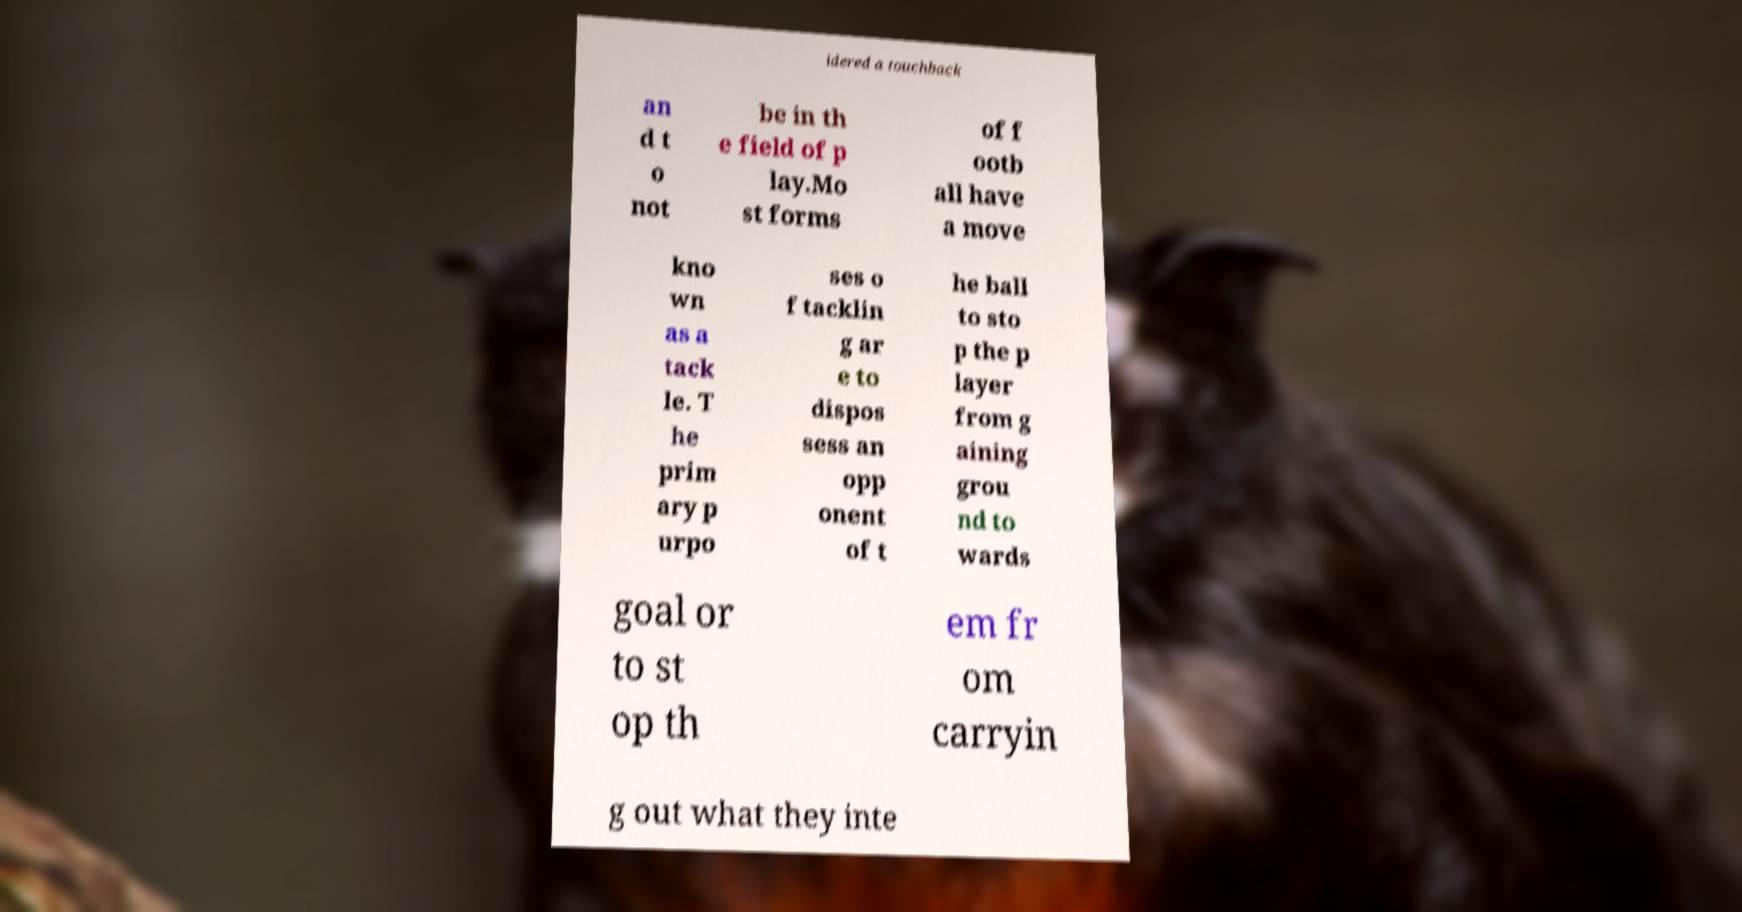Can you accurately transcribe the text from the provided image for me? idered a touchback an d t o not be in th e field of p lay.Mo st forms of f ootb all have a move kno wn as a tack le. T he prim ary p urpo ses o f tacklin g ar e to dispos sess an opp onent of t he ball to sto p the p layer from g aining grou nd to wards goal or to st op th em fr om carryin g out what they inte 